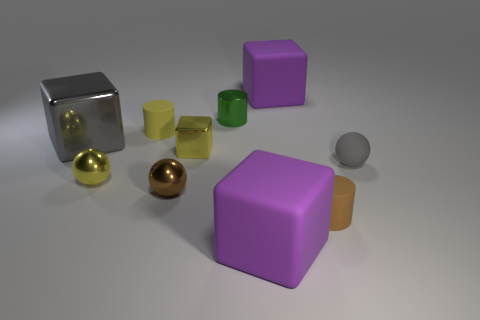Subtract all spheres. How many objects are left? 7 Subtract 0 green cubes. How many objects are left? 10 Subtract all metal balls. Subtract all tiny brown cylinders. How many objects are left? 7 Add 5 metal balls. How many metal balls are left? 7 Add 8 tiny gray metal cubes. How many tiny gray metal cubes exist? 8 